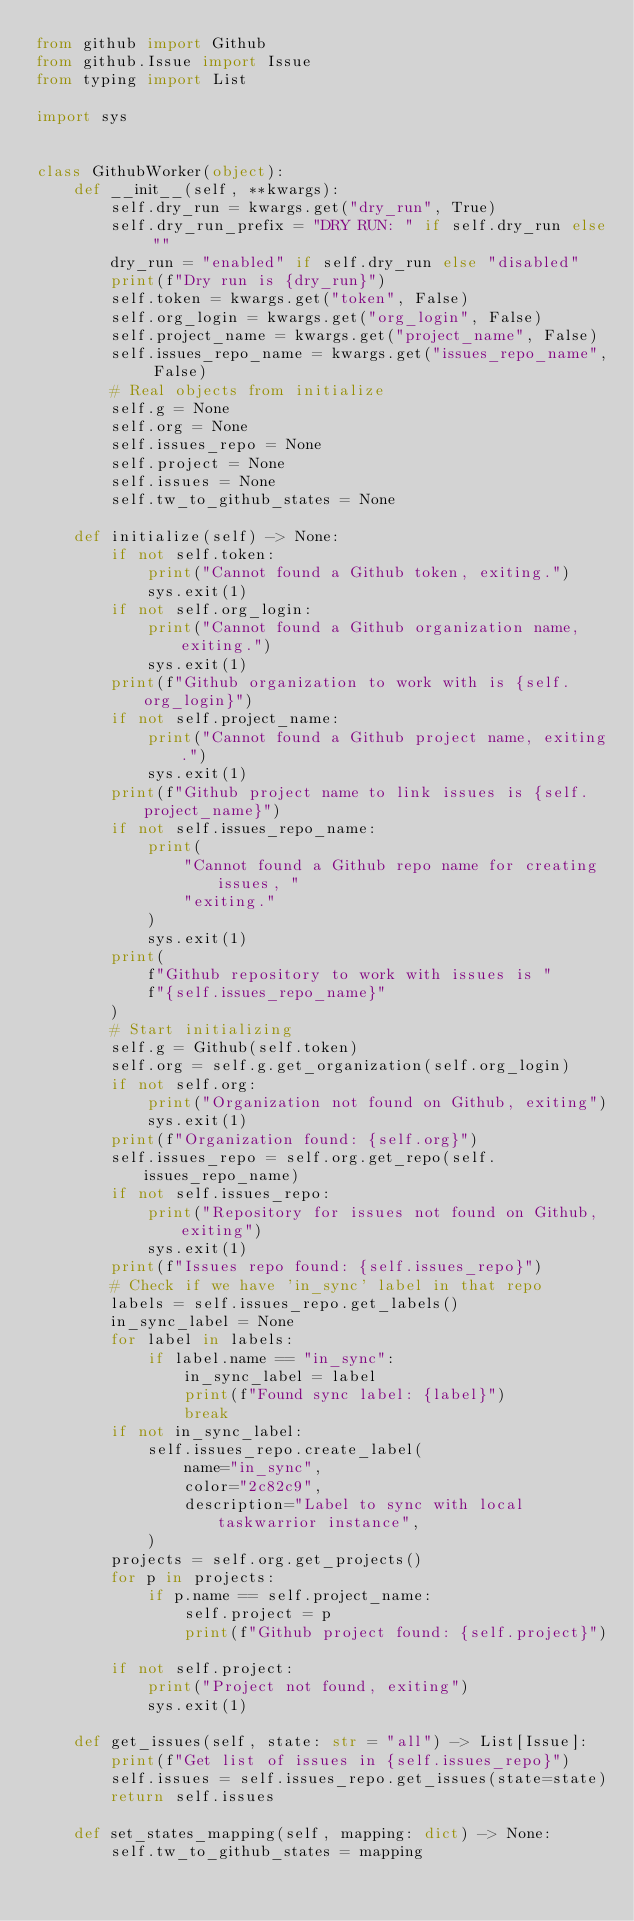Convert code to text. <code><loc_0><loc_0><loc_500><loc_500><_Python_>from github import Github
from github.Issue import Issue
from typing import List

import sys


class GithubWorker(object):
    def __init__(self, **kwargs):
        self.dry_run = kwargs.get("dry_run", True)
        self.dry_run_prefix = "DRY RUN: " if self.dry_run else ""
        dry_run = "enabled" if self.dry_run else "disabled"
        print(f"Dry run is {dry_run}")
        self.token = kwargs.get("token", False)
        self.org_login = kwargs.get("org_login", False)
        self.project_name = kwargs.get("project_name", False)
        self.issues_repo_name = kwargs.get("issues_repo_name", False)
        # Real objects from initialize
        self.g = None
        self.org = None
        self.issues_repo = None
        self.project = None
        self.issues = None
        self.tw_to_github_states = None

    def initialize(self) -> None:
        if not self.token:
            print("Cannot found a Github token, exiting.")
            sys.exit(1)
        if not self.org_login:
            print("Cannot found a Github organization name, exiting.")
            sys.exit(1)
        print(f"Github organization to work with is {self.org_login}")
        if not self.project_name:
            print("Cannot found a Github project name, exiting.")
            sys.exit(1)
        print(f"Github project name to link issues is {self.project_name}")
        if not self.issues_repo_name:
            print(
                "Cannot found a Github repo name for creating issues, "
                "exiting."
            )
            sys.exit(1)
        print(
            f"Github repository to work with issues is "
            f"{self.issues_repo_name}"
        )
        # Start initializing
        self.g = Github(self.token)
        self.org = self.g.get_organization(self.org_login)
        if not self.org:
            print("Organization not found on Github, exiting")
            sys.exit(1)
        print(f"Organization found: {self.org}")
        self.issues_repo = self.org.get_repo(self.issues_repo_name)
        if not self.issues_repo:
            print("Repository for issues not found on Github, exiting")
            sys.exit(1)
        print(f"Issues repo found: {self.issues_repo}")
        # Check if we have 'in_sync' label in that repo
        labels = self.issues_repo.get_labels()
        in_sync_label = None
        for label in labels:
            if label.name == "in_sync":
                in_sync_label = label
                print(f"Found sync label: {label}")
                break
        if not in_sync_label:
            self.issues_repo.create_label(
                name="in_sync",
                color="2c82c9",
                description="Label to sync with local taskwarrior instance",
            )
        projects = self.org.get_projects()
        for p in projects:
            if p.name == self.project_name:
                self.project = p
                print(f"Github project found: {self.project}")

        if not self.project:
            print("Project not found, exiting")
            sys.exit(1)

    def get_issues(self, state: str = "all") -> List[Issue]:
        print(f"Get list of issues in {self.issues_repo}")
        self.issues = self.issues_repo.get_issues(state=state)
        return self.issues

    def set_states_mapping(self, mapping: dict) -> None:
        self.tw_to_github_states = mapping
</code> 